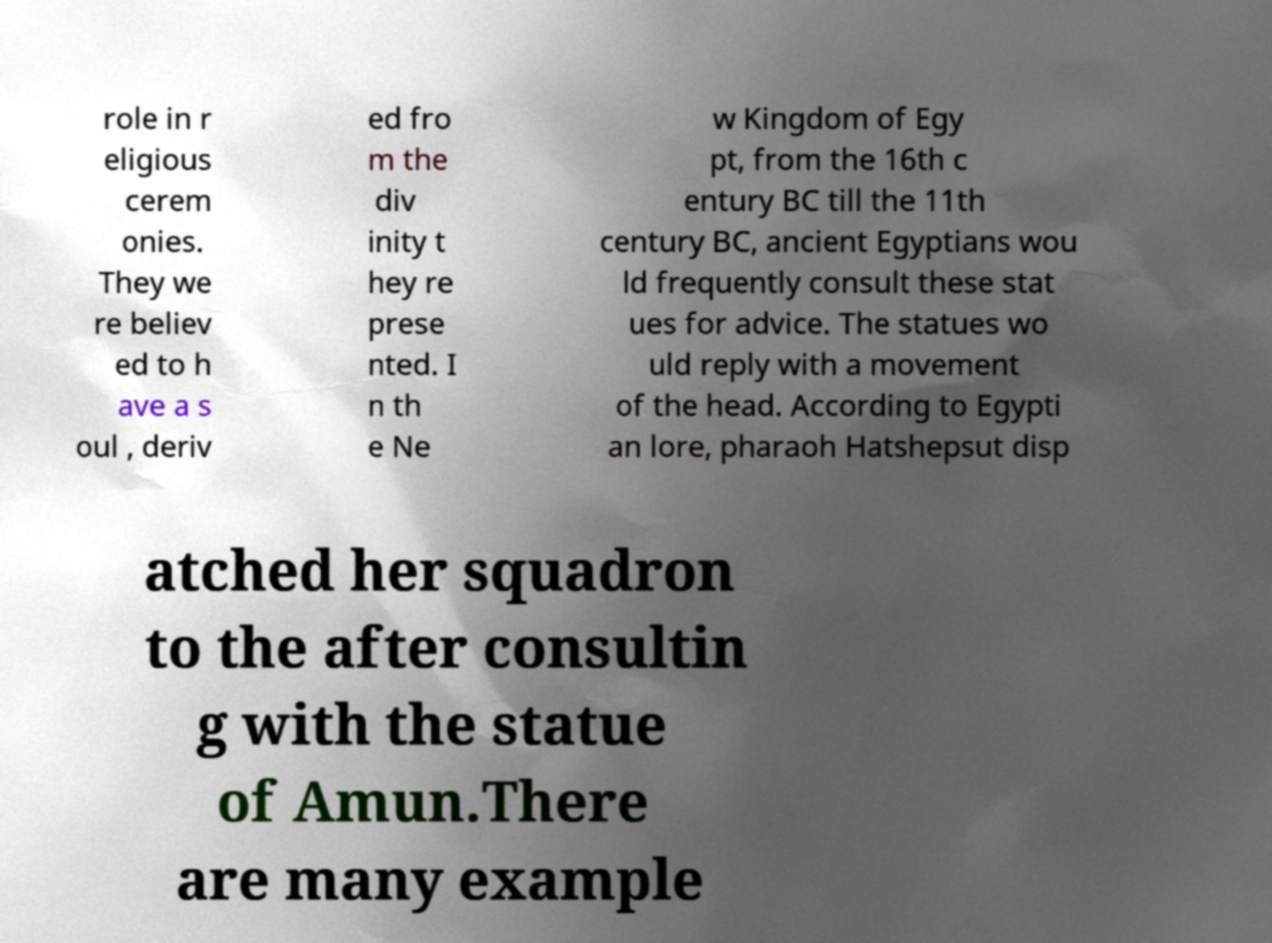For documentation purposes, I need the text within this image transcribed. Could you provide that? role in r eligious cerem onies. They we re believ ed to h ave a s oul , deriv ed fro m the div inity t hey re prese nted. I n th e Ne w Kingdom of Egy pt, from the 16th c entury BC till the 11th century BC, ancient Egyptians wou ld frequently consult these stat ues for advice. The statues wo uld reply with a movement of the head. According to Egypti an lore, pharaoh Hatshepsut disp atched her squadron to the after consultin g with the statue of Amun.There are many example 